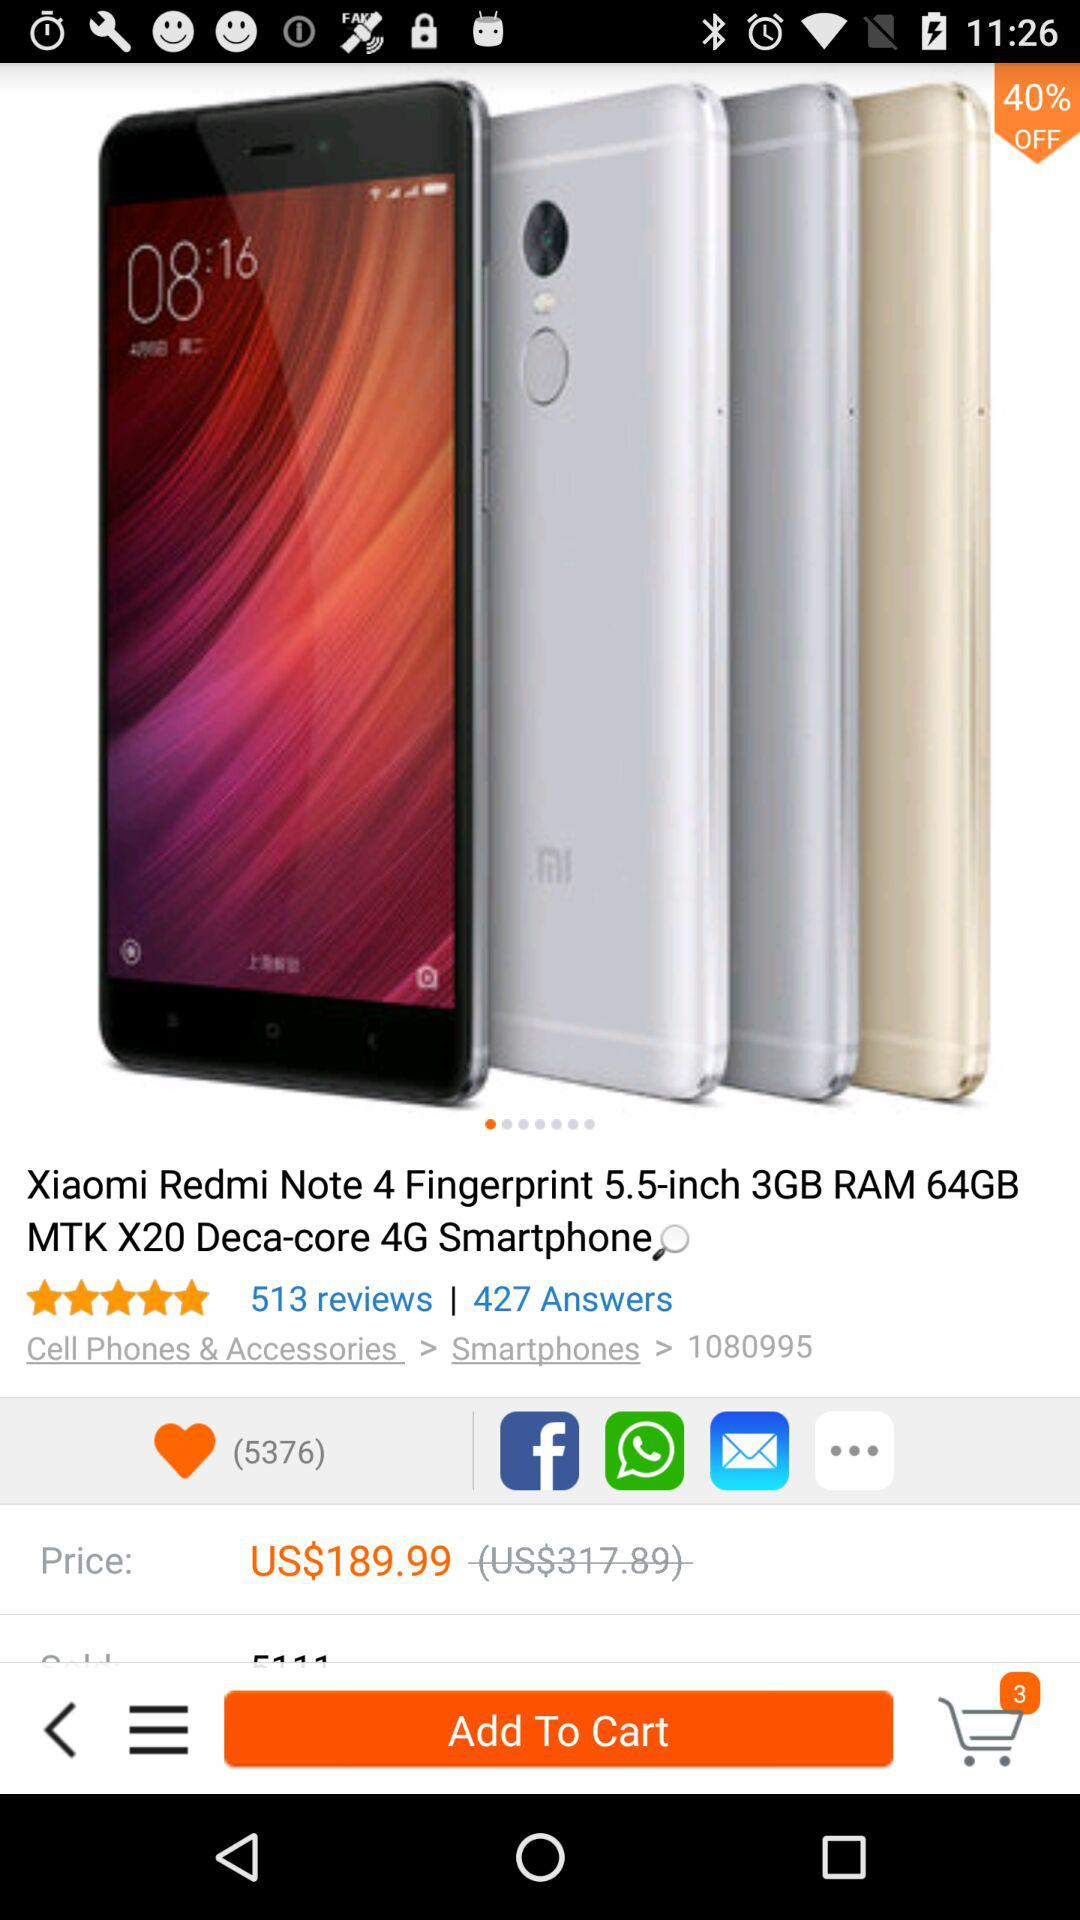How many items are in the cart? There are 3 items in the cart. 